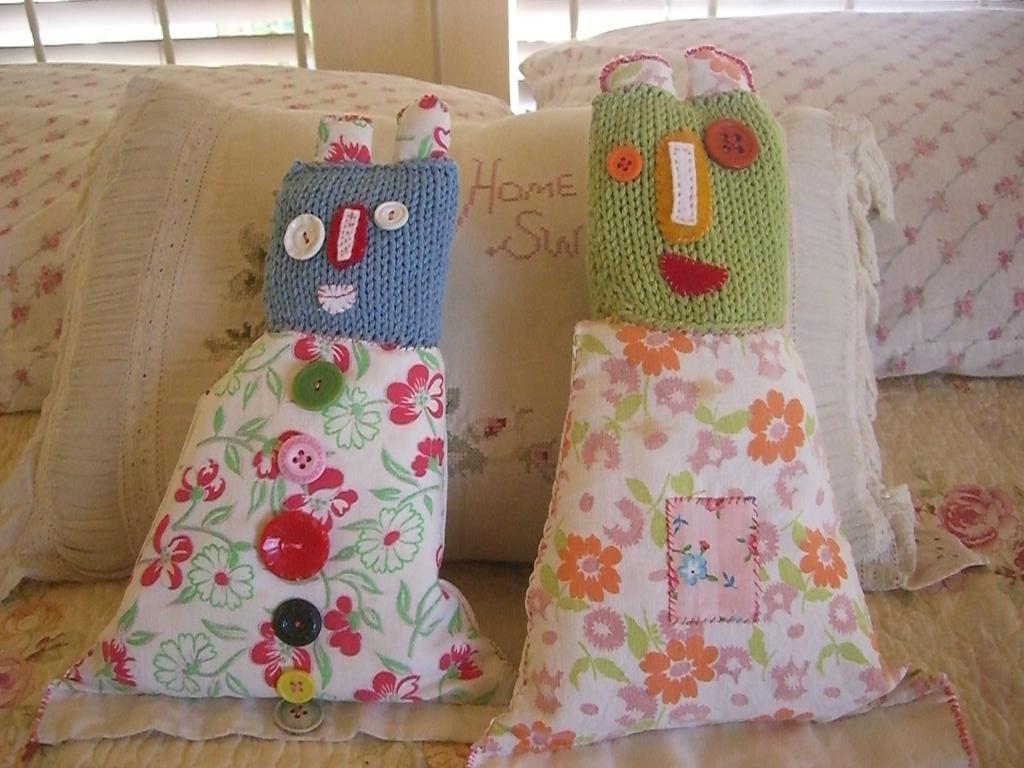Describe this image in one or two sentences. In this image I see the couch on which there are cushions and I see something is written over here. 